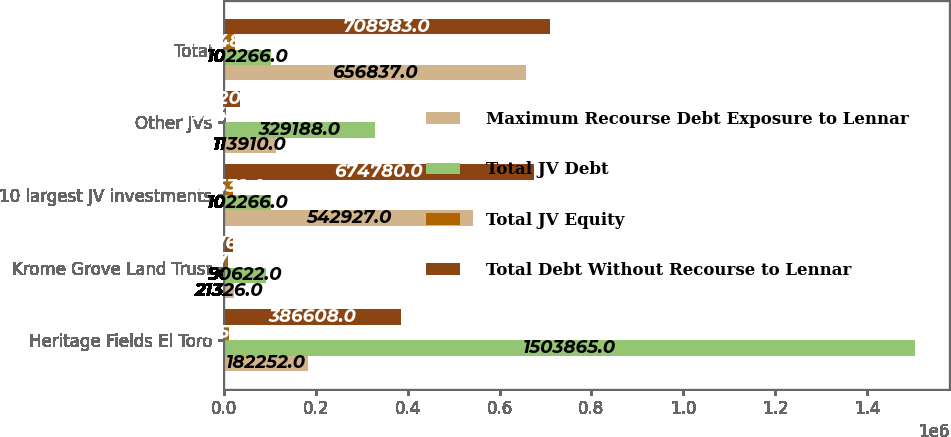<chart> <loc_0><loc_0><loc_500><loc_500><stacked_bar_chart><ecel><fcel>Heritage Fields El Toro<fcel>Krome Grove Land Trust<fcel>10 largest JV investments<fcel>Other JVs<fcel>Total<nl><fcel>Maximum Recourse Debt Exposure to Lennar<fcel>182252<fcel>21326<fcel>542927<fcel>113910<fcel>656837<nl><fcel>Total JV Debt<fcel>1.50386e+06<fcel>90622<fcel>102266<fcel>329188<fcel>102266<nl><fcel>Total JV Equity<fcel>11256<fcel>9276<fcel>20532<fcel>3949<fcel>24481<nl><fcel>Total Debt Without Recourse to Lennar<fcel>386608<fcel>19761<fcel>674780<fcel>34203<fcel>708983<nl></chart> 